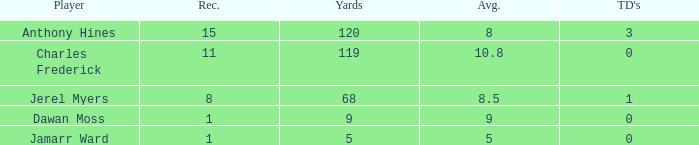What is the average number of TDs when the yards are less than 119, the AVG is larger than 5, and Jamarr Ward is a player? None. 